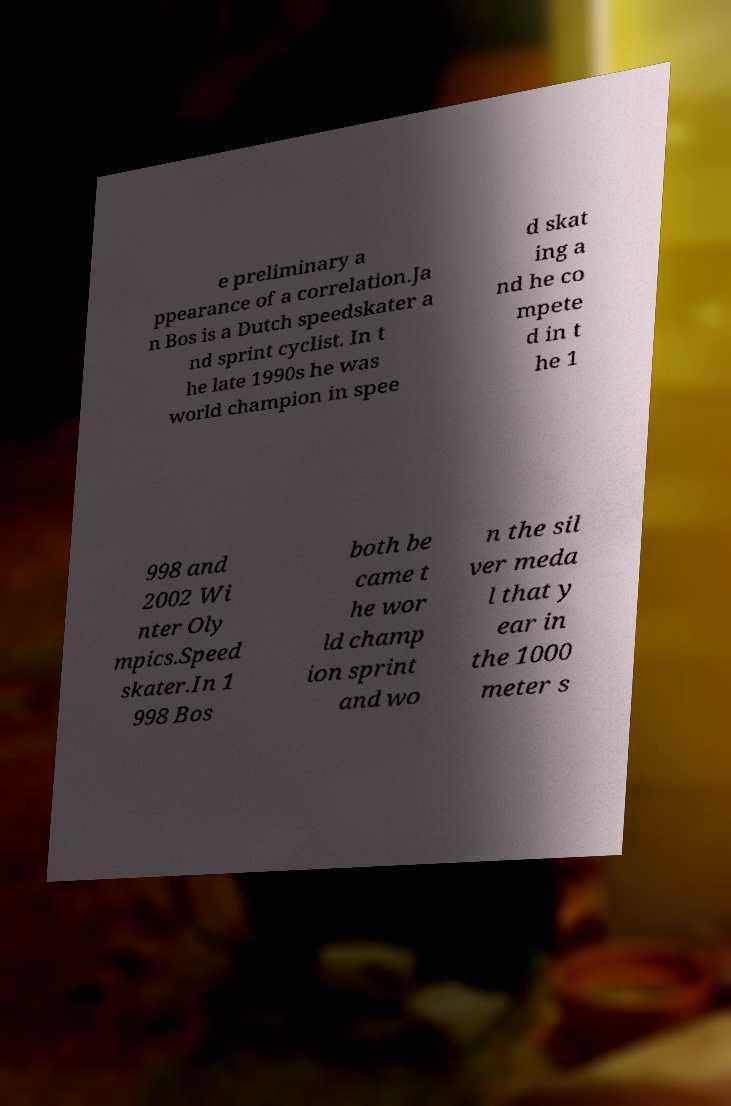Can you read and provide the text displayed in the image?This photo seems to have some interesting text. Can you extract and type it out for me? e preliminary a ppearance of a correlation.Ja n Bos is a Dutch speedskater a nd sprint cyclist. In t he late 1990s he was world champion in spee d skat ing a nd he co mpete d in t he 1 998 and 2002 Wi nter Oly mpics.Speed skater.In 1 998 Bos both be came t he wor ld champ ion sprint and wo n the sil ver meda l that y ear in the 1000 meter s 